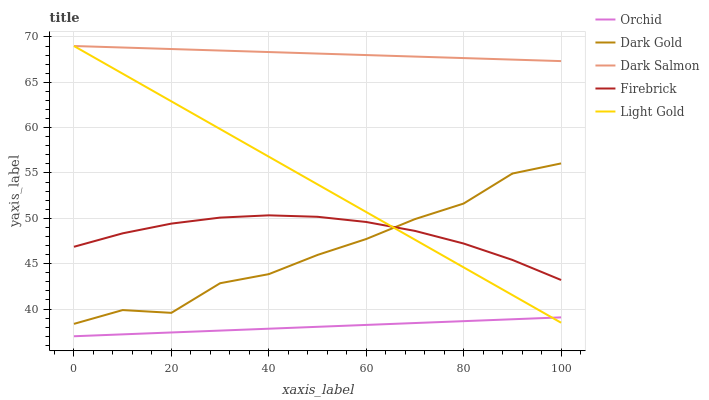Does Orchid have the minimum area under the curve?
Answer yes or no. Yes. Does Dark Salmon have the maximum area under the curve?
Answer yes or no. Yes. Does Dark Gold have the minimum area under the curve?
Answer yes or no. No. Does Dark Gold have the maximum area under the curve?
Answer yes or no. No. Is Orchid the smoothest?
Answer yes or no. Yes. Is Dark Gold the roughest?
Answer yes or no. Yes. Is Light Gold the smoothest?
Answer yes or no. No. Is Light Gold the roughest?
Answer yes or no. No. Does Orchid have the lowest value?
Answer yes or no. Yes. Does Dark Gold have the lowest value?
Answer yes or no. No. Does Dark Salmon have the highest value?
Answer yes or no. Yes. Does Dark Gold have the highest value?
Answer yes or no. No. Is Dark Gold less than Dark Salmon?
Answer yes or no. Yes. Is Dark Salmon greater than Firebrick?
Answer yes or no. Yes. Does Light Gold intersect Dark Salmon?
Answer yes or no. Yes. Is Light Gold less than Dark Salmon?
Answer yes or no. No. Is Light Gold greater than Dark Salmon?
Answer yes or no. No. Does Dark Gold intersect Dark Salmon?
Answer yes or no. No. 